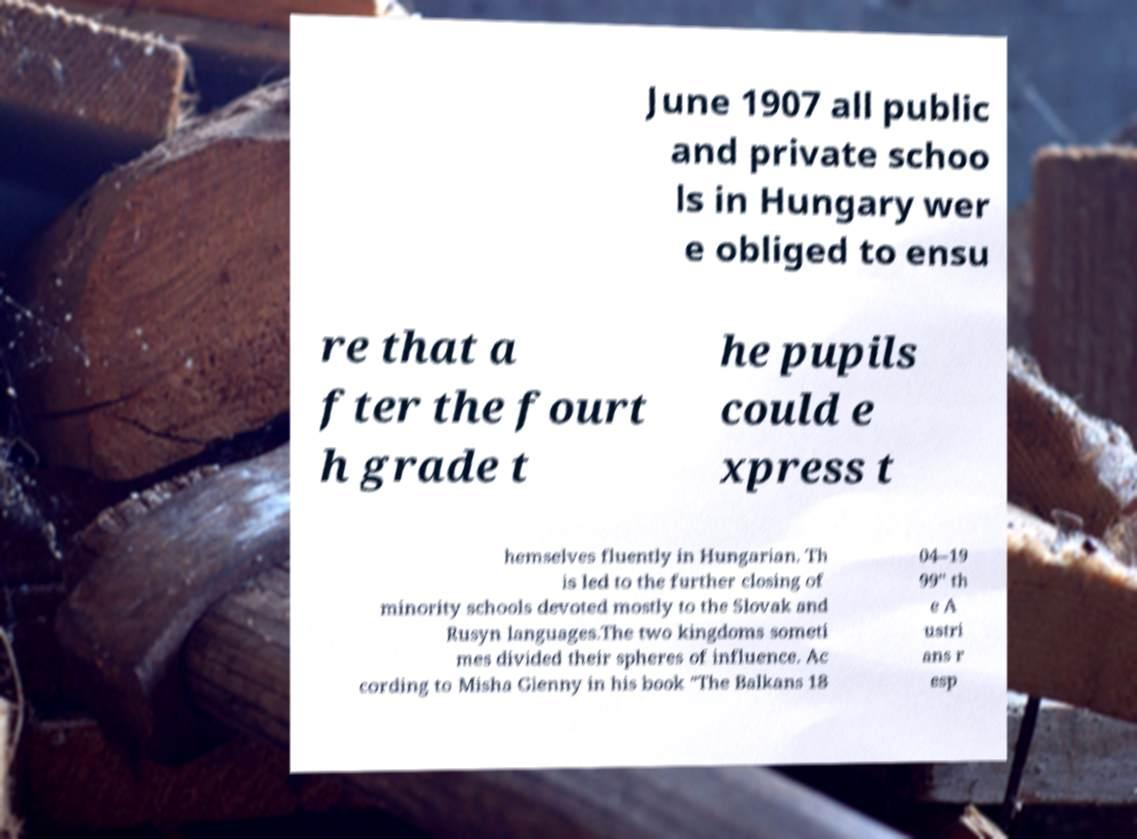For documentation purposes, I need the text within this image transcribed. Could you provide that? June 1907 all public and private schoo ls in Hungary wer e obliged to ensu re that a fter the fourt h grade t he pupils could e xpress t hemselves fluently in Hungarian. Th is led to the further closing of minority schools devoted mostly to the Slovak and Rusyn languages.The two kingdoms someti mes divided their spheres of influence. Ac cording to Misha Glenny in his book "The Balkans 18 04–19 99" th e A ustri ans r esp 